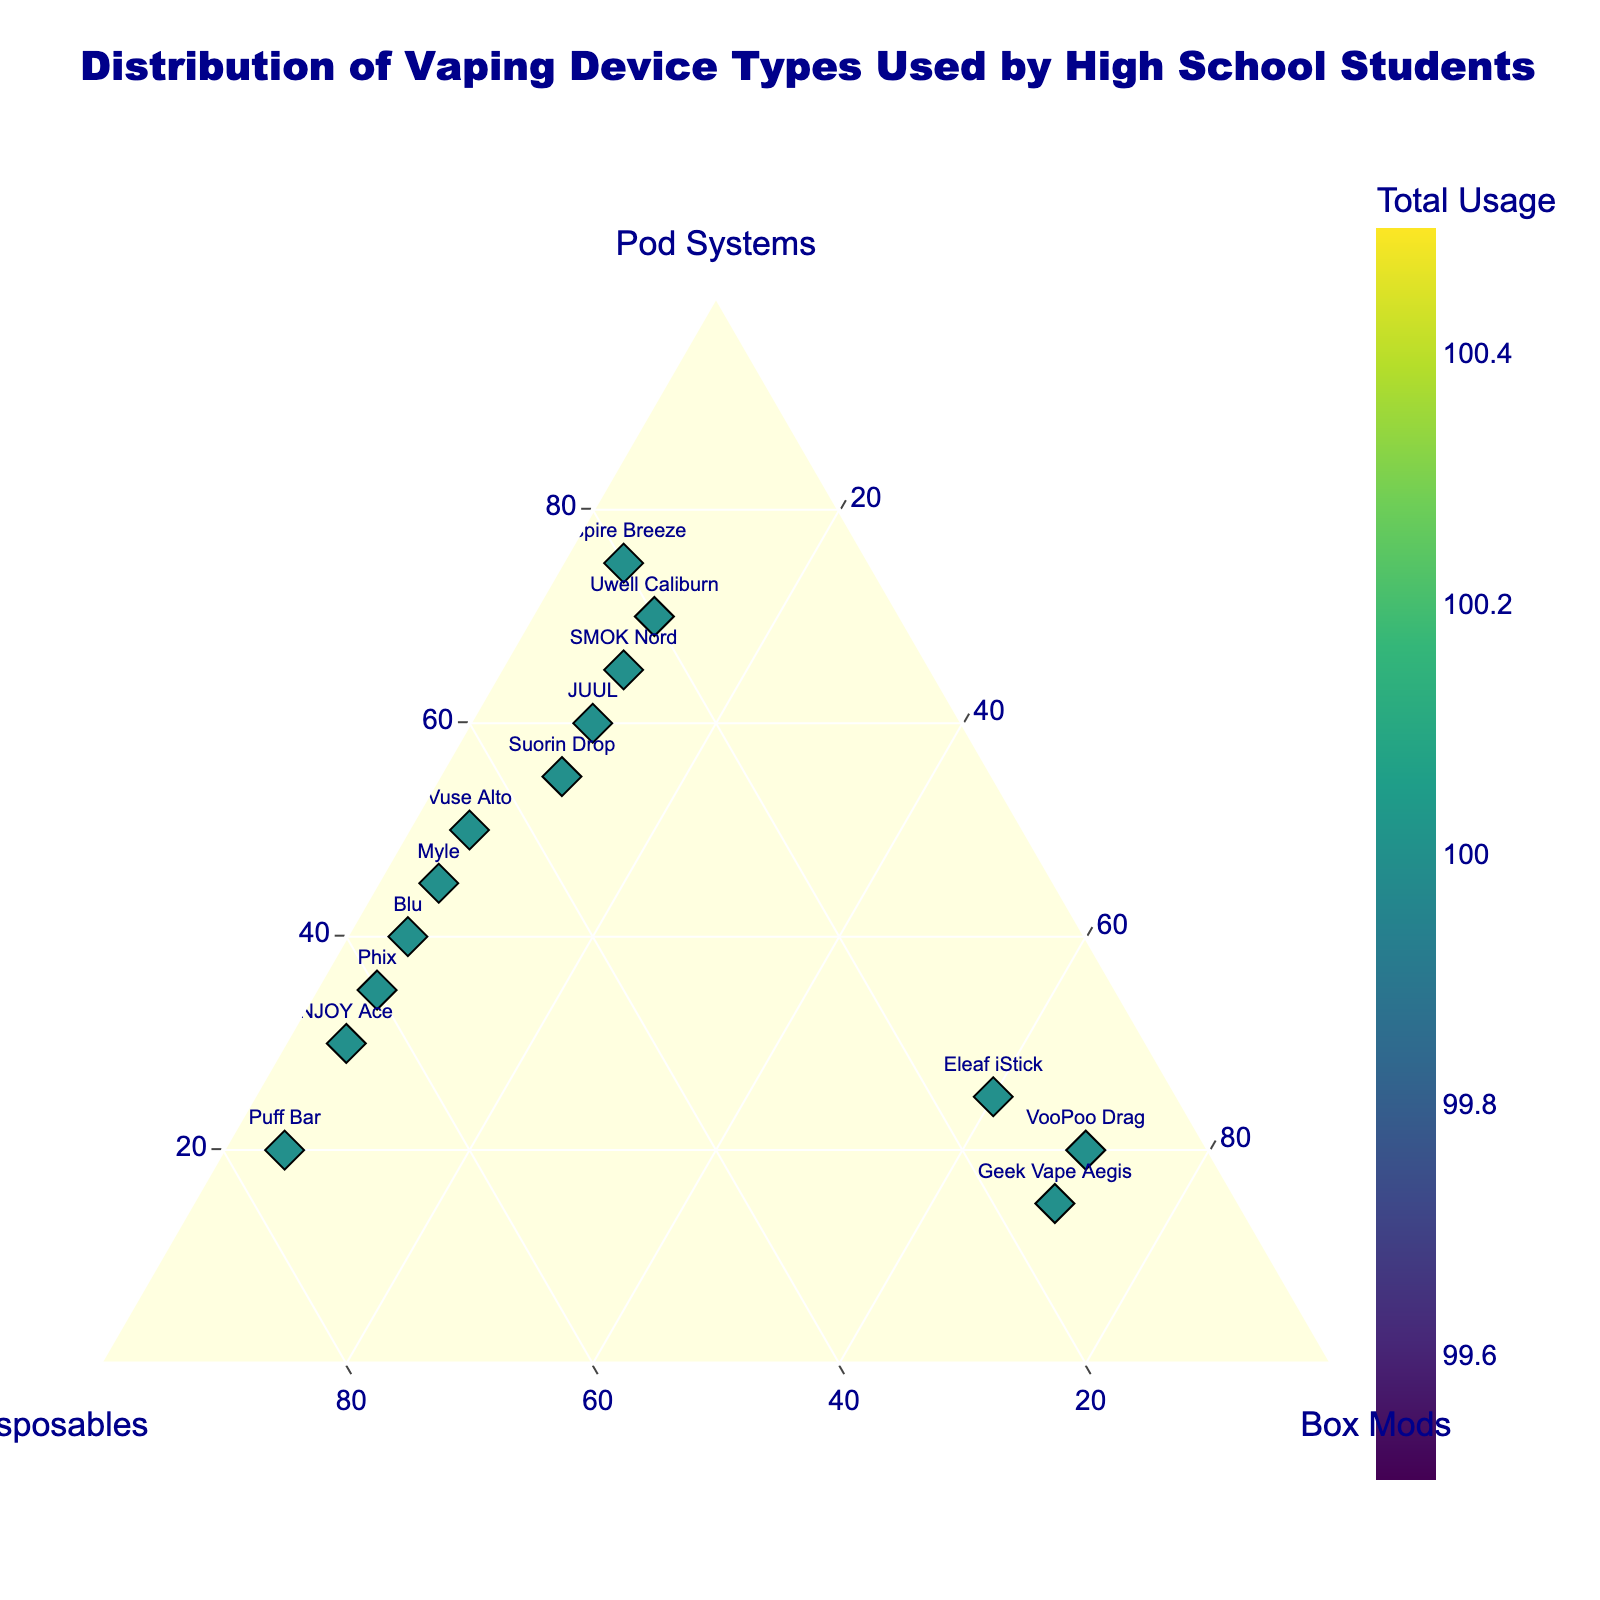What is the title of the plot? Look at the top of the figure. The title provides a summary of what the plot is about.
Answer: Distribution of Vaping Device Types Used by High School Students How many different vaping devices are represented in the plot? Count the number of distinct text labels (representing each vaping device) within the plot.
Answer: 14 Which vaping device has the highest percentage of Pod Systems usage? Find the point that is furthest along the axis labelled "Pod Systems" and check the corresponding text label.
Answer: Aspire Breeze Which device has the most balanced usage across Pod Systems, Disposables, and Box Mods? Look for a point that is closest to the center of the ternary plot, indicating even percentages among the three categories.
Answer: Suorin Drop Which device has the highest total usage? Check the color intensity of the points, as the color scale represents total usage.
Answer: SMOK Nord How does Puff Bar compare to NJOY Ace in terms of Disposable usage? Locate the points for Puff Bar and NJOY Ace, then compare their positions along the "Disposables" axis.
Answer: Puff Bar has higher Disposable usage than NJOY Ace What is the average percentage of Pod Systems usage for all devices? Compute the average of the percentages on the "Pod Systems" axis for all devices. Add up these percentages and divide by the number of devices.
Answer: 43.57% Which device is predominantly used as a Box Mod? Look for the points farthest along the "Box Mods" axis and check their corresponding text labels.
Answer: Geek Vape Aegis and VooPoo Drag Compare the Pod Systems usage of Blu and Vuse Alto. Which one is higher? Locate Blu and Vuse Alto on the ternary plot and compare their positions along the "Pod Systems" axis.
Answer: Vuse Alto has higher Pod Systems usage than Blu What are the Pod Systems, Disposables, and Box Mods percentages for JUUL? Hover over the JUUL data point to view the hover information which lists the specific percentages for each category.
Answer: Pod Systems: 60%, Disposables: 30%, Box Mods: 10% 